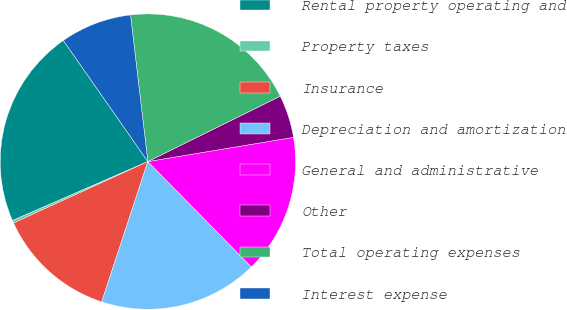<chart> <loc_0><loc_0><loc_500><loc_500><pie_chart><fcel>Rental property operating and<fcel>Property taxes<fcel>Insurance<fcel>Depreciation and amortization<fcel>General and administrative<fcel>Other<fcel>Total operating expenses<fcel>Interest expense<nl><fcel>21.84%<fcel>0.29%<fcel>13.11%<fcel>17.42%<fcel>15.26%<fcel>4.68%<fcel>19.57%<fcel>7.82%<nl></chart> 